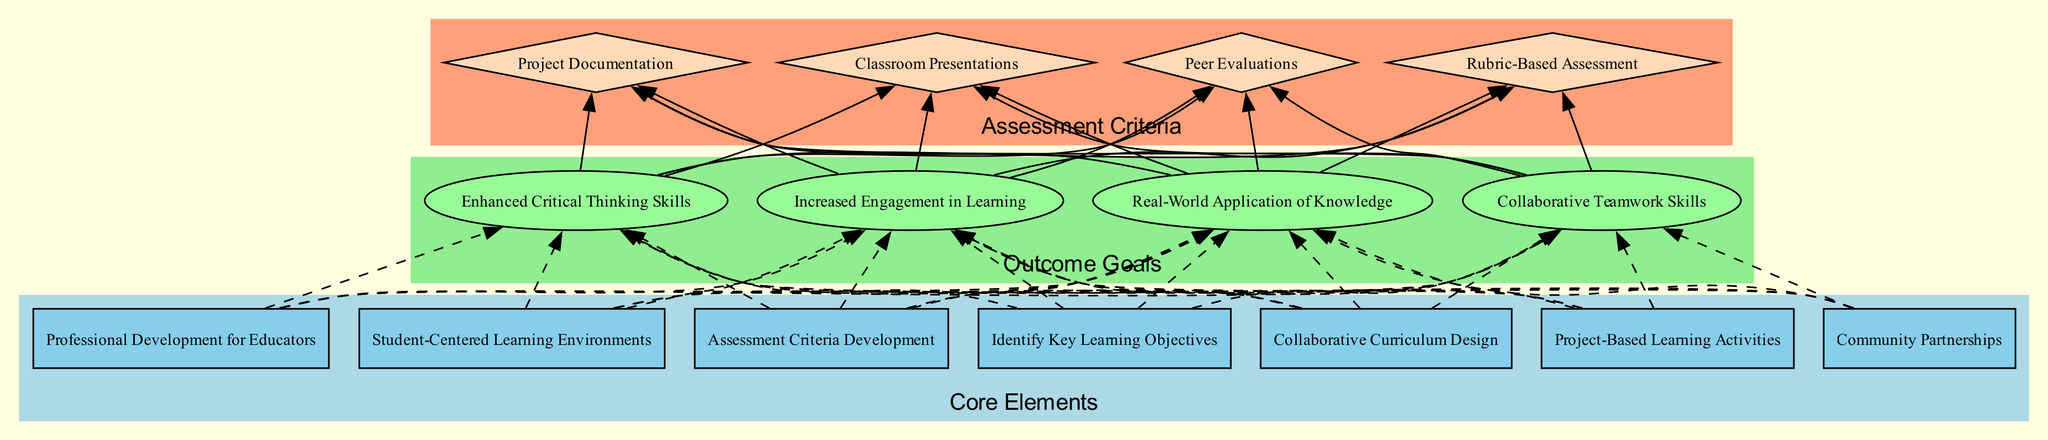What are the core elements in the curriculum integration plan? The core elements are listed in the designated area of the diagram that groups together related information. There are six specific elements: Identify Key Learning Objectives, Collaborative Curriculum Design, Project-Based Learning Activities, Community Partnerships, Professional Development for Educators, and Student-Centered Learning Environments.
Answer: Identify Key Learning Objectives, Collaborative Curriculum Design, Project-Based Learning Activities, Community Partnerships, Professional Development for Educators, Student-Centered Learning Environments How many outcome goals are defined? The outcome goals are represented in a specific section of the diagram. There are four distinctly defined goals: Enhanced Critical Thinking Skills, Increased Engagement in Learning, Real-World Application of Knowledge, and Collaborative Teamwork Skills, which can be counted directly.
Answer: 4 What connects Core Elements to Outcome Goals in the diagram? The connections from Core Elements to Outcome Goals are represented as dashed edges, indicating the relationship. Each core element points to all four outcome goals, reflecting how the elements contribute to achieving these goals.
Answer: Dashed edges Which assessment criteria correspond to the goal of Increased Engagement in Learning? To find the assessment criteria for this goal, the diagram should be followed from the Increased Engagement in Learning node. From this goal, the edges lead to all assessment criteria—Project Documentation, Classroom Presentations, Peer Evaluations, and Rubric-Based Assessment—all apply, but connections can be specifically verified from the diagram layout.
Answer: Project Documentation, Classroom Presentations, Peer Evaluations, Rubric-Based Assessment Which core element has the most connections to outcome goals? In the diagram, each core element should have edges leading to the outcome goals. As it is laid out, all core elements are connected to all four outcome goals—this indicates that the connections are equal among all, thus confirming there isn't a core element with more connections than others in this design.
Answer: All core elements have equal connections Explain the relationship between Project-Based Learning Activities and Collaborative Teamwork Skills. The Project-Based Learning Activities node connects to the Collaborative Teamwork Skills through a dashed edge. This signifies that the hands-on projects developed under this core element directly enhance students' teamwork abilities, highlighting a clear linkage in the curriculum's design logic.
Answer: They are connected by a dashed edge What type of nodes represent the assessment criteria in the diagram? Observing the diagram, assessment criteria are specifically represented by diamond-shaped nodes. This shape indicates their distinct role in the evaluation process within the curriculum integration plan, differentiating them from core elements and outcome goals.
Answer: Diamond-shaped nodes What is the purpose of the Professional Development for Educators core element? The diagram provides a clear description under the Professional Development for Educators node, stating that it offers training workshops and resources for educators to incorporate STEAM practices. Thus, its purpose relates to enhancing teacher capabilities in using STEAM methodologies in their classrooms.
Answer: To offer training workshops and resources for teachers How do community partnerships support the curriculum integration plan? Looking at the Community Partnerships node, it describes forming alliances with local businesses and organizations. This supports the integration plan by providing real-world applications and resources, which enrich the learning experience and connect academic knowledge to practical instances.
Answer: They provide real-world applications and resources 